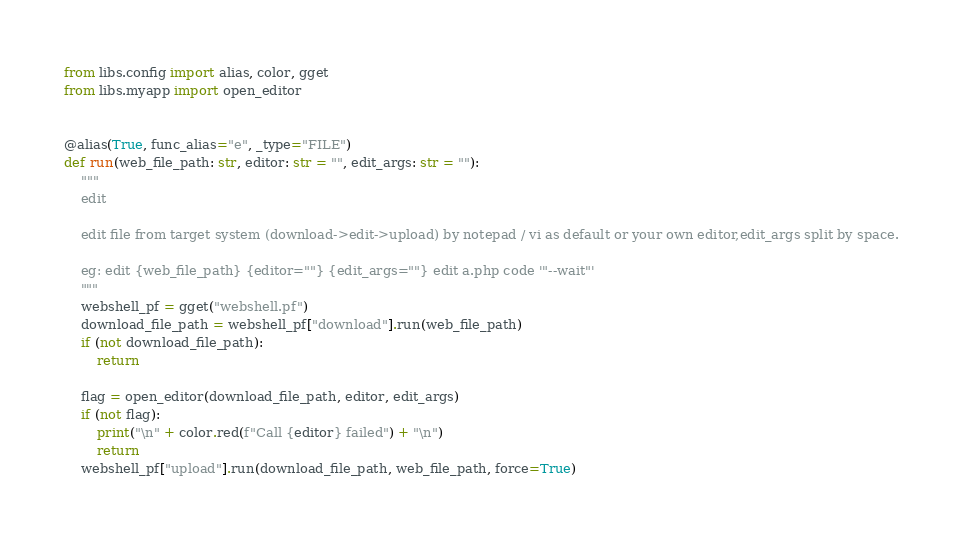<code> <loc_0><loc_0><loc_500><loc_500><_Python_>from libs.config import alias, color, gget
from libs.myapp import open_editor


@alias(True, func_alias="e", _type="FILE")
def run(web_file_path: str, editor: str = "", edit_args: str = ""):
    """
    edit

    edit file from target system (download->edit->upload) by notepad / vi as default or your own editor,edit_args split by space.

    eg: edit {web_file_path} {editor=""} {edit_args=""} edit a.php code '"--wait"'
    """
    webshell_pf = gget("webshell.pf")
    download_file_path = webshell_pf["download"].run(web_file_path)
    if (not download_file_path):
        return

    flag = open_editor(download_file_path, editor, edit_args)
    if (not flag):
        print("\n" + color.red(f"Call {editor} failed") + "\n")
        return
    webshell_pf["upload"].run(download_file_path, web_file_path, force=True)
</code> 